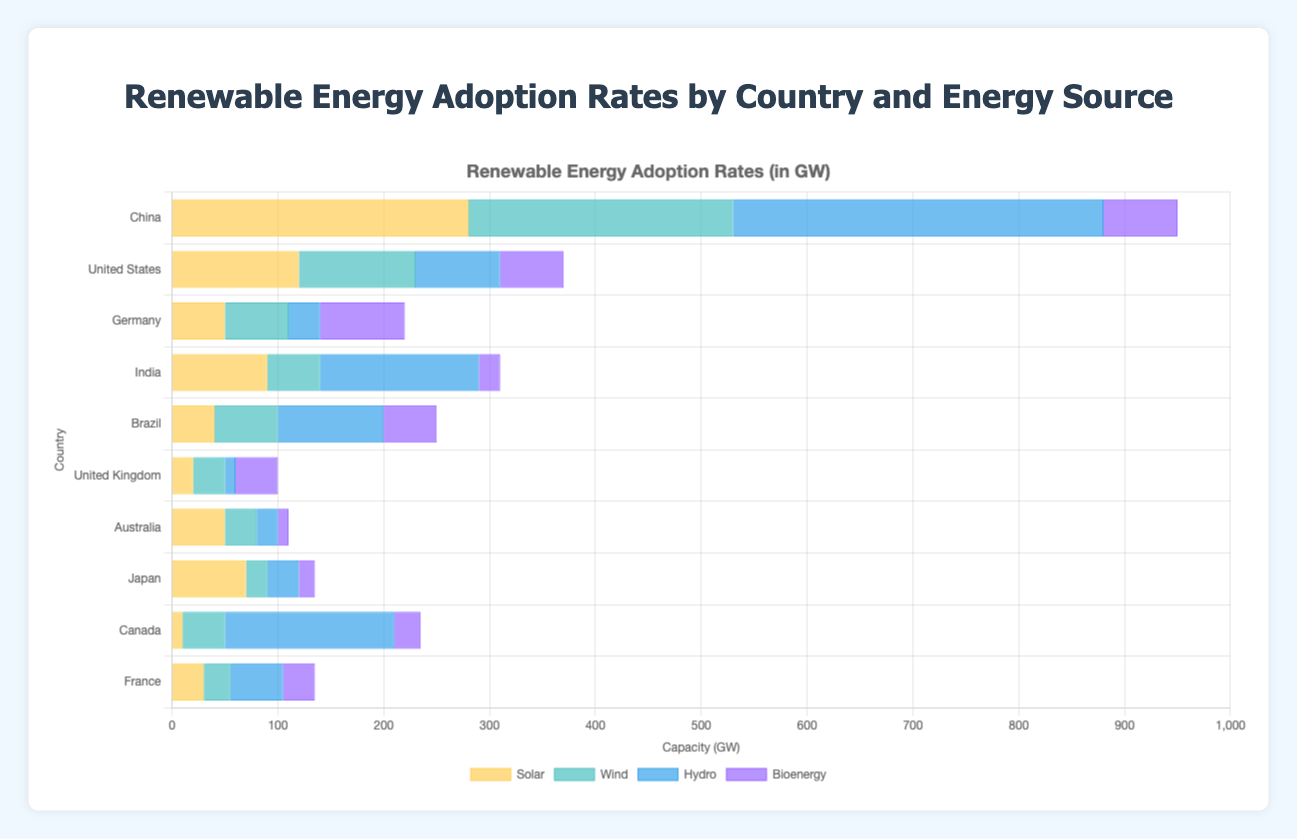Which country has the highest hydro energy adoption rate? Observing the heights of the bars representing hydro energy, China has the tallest bar at 350 GW, indicating the highest hydro energy adoption rate.
Answer: China Which two countries have the closest solar energy adoption rates? Looking at the horizontal bars for solar energy, Germany and Australia have similar bar lengths with values of 50 GW each.
Answer: Germany and Australia What's the total renewable energy adoption rate in the United States? Summing up the adoption rates for solar (120 GW), wind (110 GW), hydro (80 GW), and bioenergy (60 GW) in the United States provides the total renewable energy adoption rate: 120 + 110 + 80 + 60 = 370 GW.
Answer: 370 GW Which country has a greater wind energy adoption rate, France or Canada? Comparing the lengths of the bars for wind energy, Canada's bar (40 GW) is longer than France's (25 GW), indicating a greater wind energy adoption rate for Canada.
Answer: Canada What is the average solar energy adoption rate among China, India, and Japan? Summing the solar energy rates for China (280 GW), India (90 GW), and Japan (70 GW) and then dividing by the number of countries: (280 + 90 + 70) / 3 = 440 / 3 ≈ 146.7 GW.
Answer: 146.7 GW Which energy source has the lowest adoption rate in the United Kingdom? Among the bars for solar (20 GW), wind (30 GW), hydro (10 GW), and bioenergy (40 GW) in the United Kingdom, the hydro bar is the shortest at 10 GW, indicating the lowest adoption rate.
Answer: Hydro How much more hydro energy does China adopt compared to Brazil? Subtracting Brazil's hydro rate (100 GW) from China's (350 GW) gives the difference: 350 - 100 = 250 GW.
Answer: 250 GW Among the listed countries, which one has the highest bioenergy adoption rate? Observing the lengths of the bars for bioenergy across all countries, Germany has the tallest bar at 80 GW.
Answer: Germany What is the combined wind energy adoption rate for Germany and India? Adding Germany's wind energy (60 GW) and India's wind energy (50 GW) gives the total: 60 + 50 = 110 GW.
Answer: 110 GW 